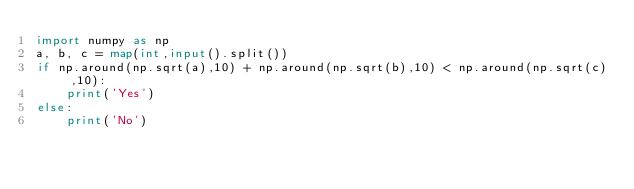Convert code to text. <code><loc_0><loc_0><loc_500><loc_500><_Python_>import numpy as np
a, b, c = map(int,input().split())
if np.around(np.sqrt(a),10) + np.around(np.sqrt(b),10) < np.around(np.sqrt(c),10):
    print('Yes')
else:
    print('No')</code> 